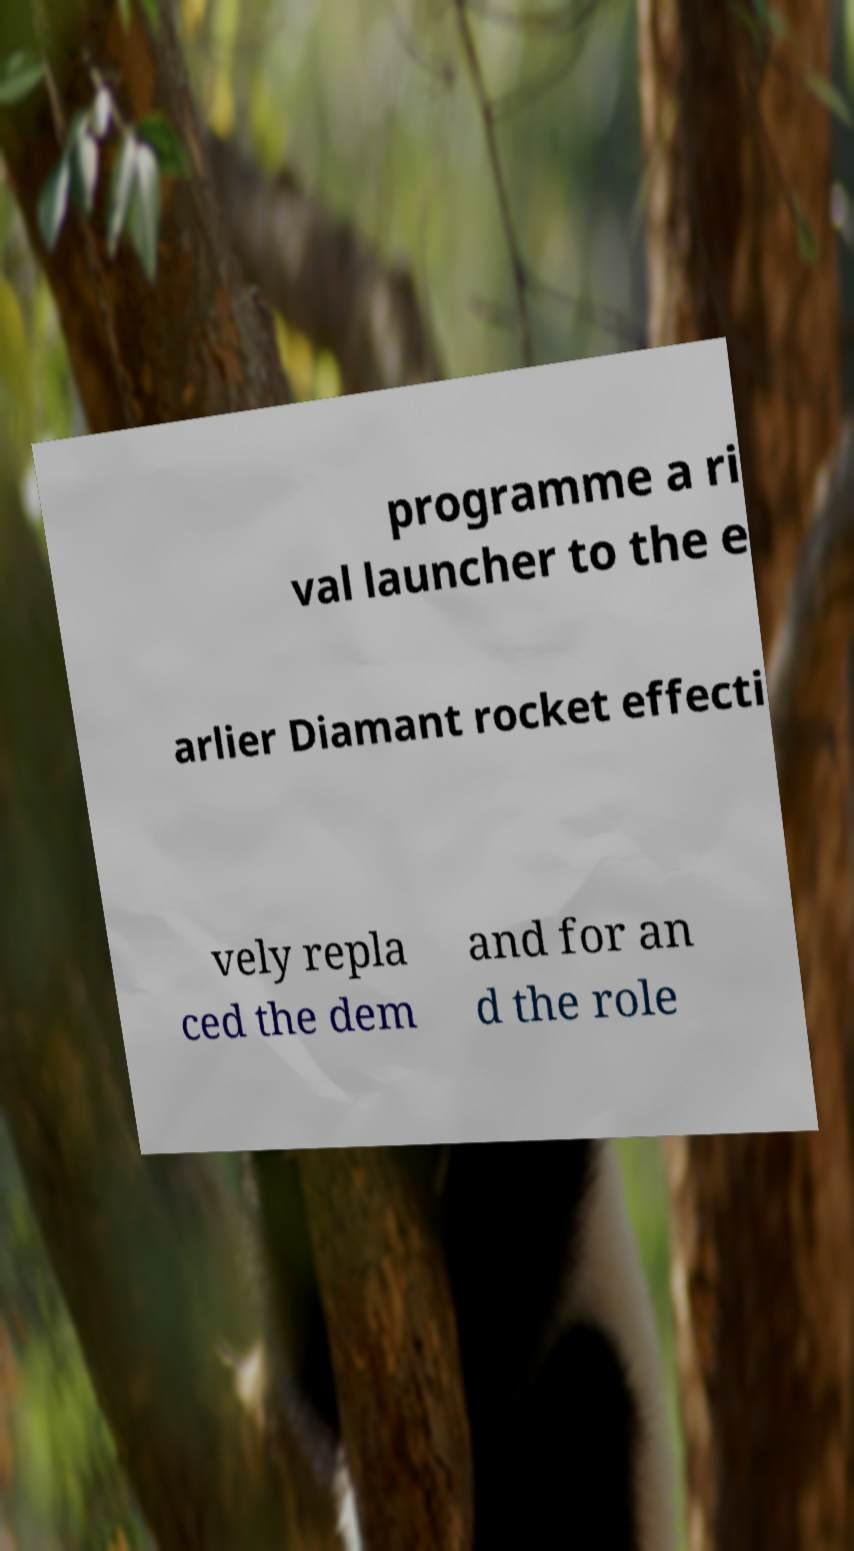There's text embedded in this image that I need extracted. Can you transcribe it verbatim? programme a ri val launcher to the e arlier Diamant rocket effecti vely repla ced the dem and for an d the role 